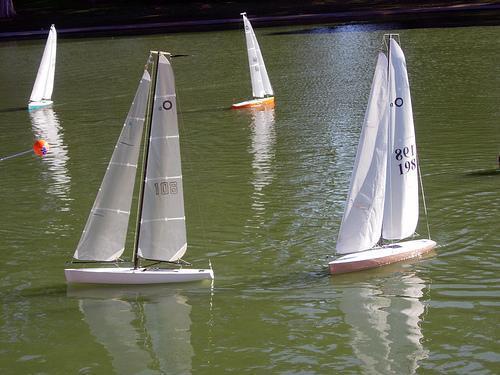How many sailboats on the water?
Give a very brief answer. 4. 